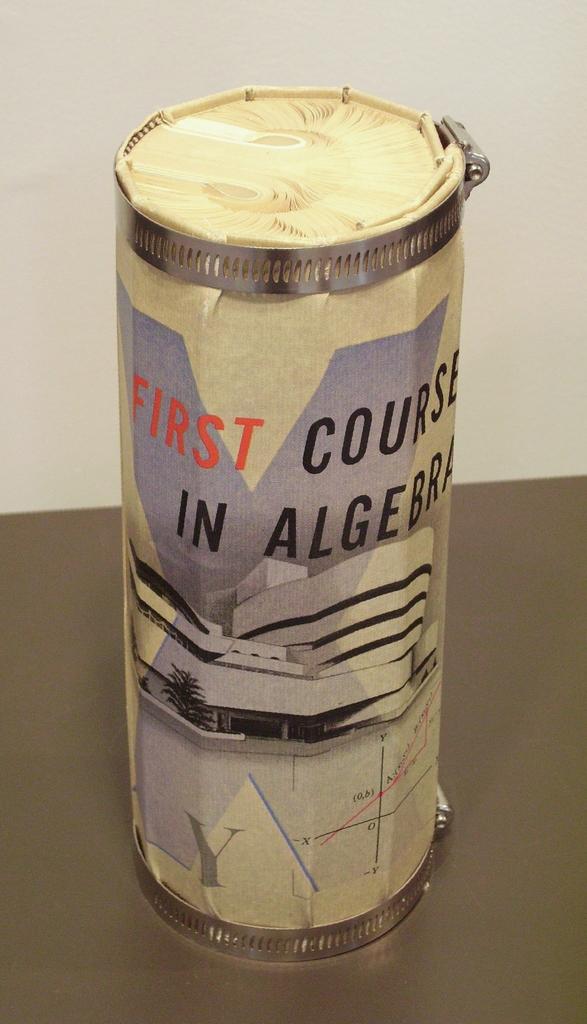What is the first word in red text on the can?
Your response must be concise. First. In what is this first course for?
Keep it short and to the point. Algebra. 